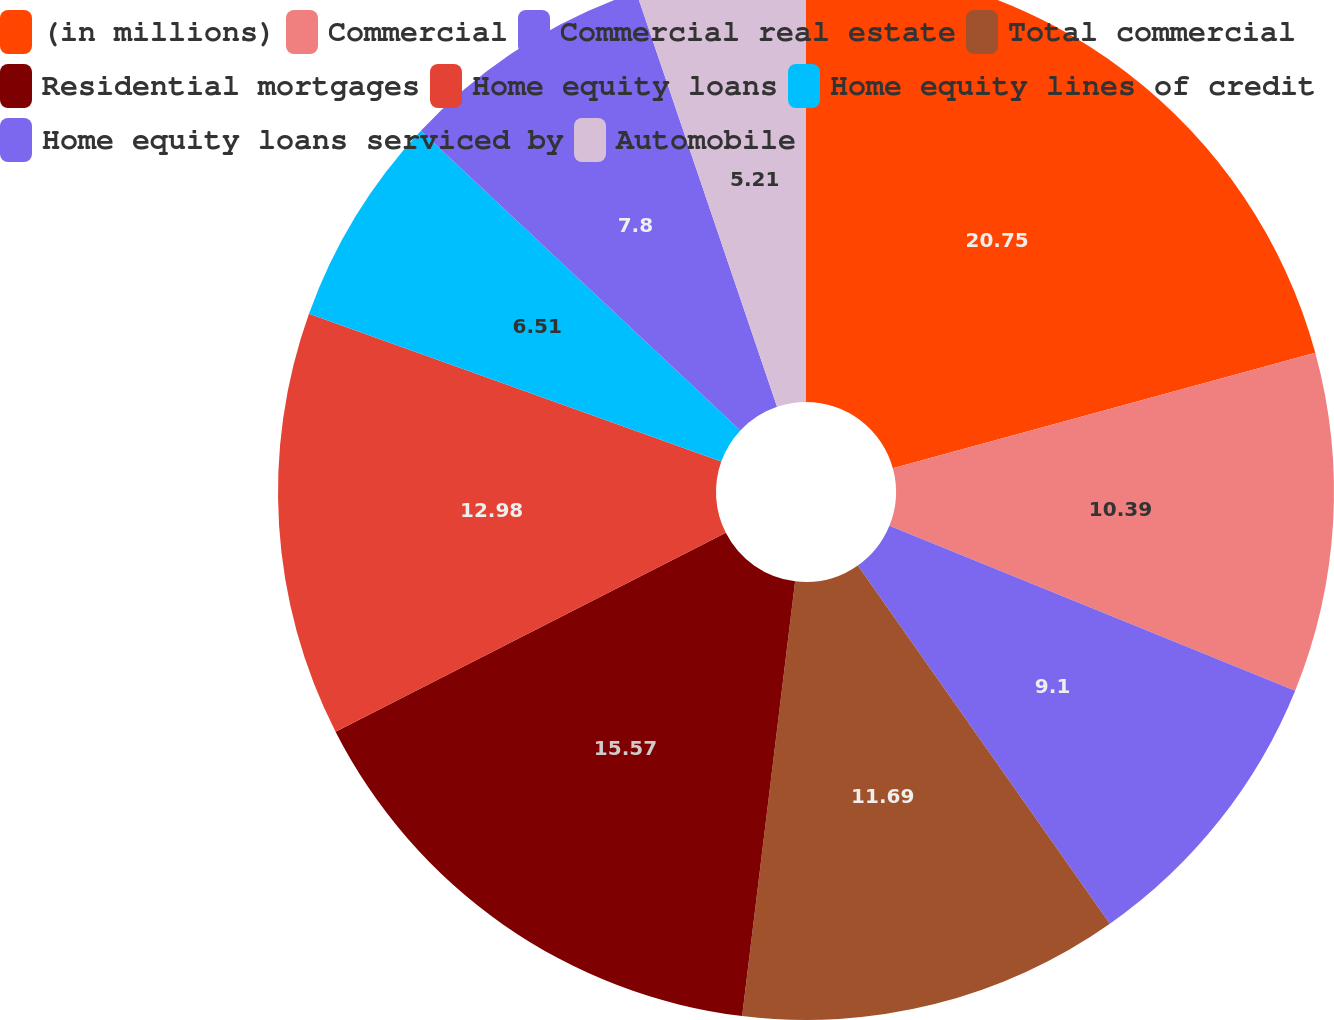Convert chart to OTSL. <chart><loc_0><loc_0><loc_500><loc_500><pie_chart><fcel>(in millions)<fcel>Commercial<fcel>Commercial real estate<fcel>Total commercial<fcel>Residential mortgages<fcel>Home equity loans<fcel>Home equity lines of credit<fcel>Home equity loans serviced by<fcel>Automobile<nl><fcel>20.75%<fcel>10.39%<fcel>9.1%<fcel>11.69%<fcel>15.57%<fcel>12.98%<fcel>6.51%<fcel>7.8%<fcel>5.21%<nl></chart> 